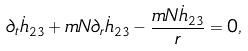<formula> <loc_0><loc_0><loc_500><loc_500>\partial _ { t } \dot { h } _ { 2 3 } + m N \partial _ { r } \dot { h } _ { 2 3 } - \frac { m N \dot { h } _ { 2 3 } } { r } = 0 ,</formula> 